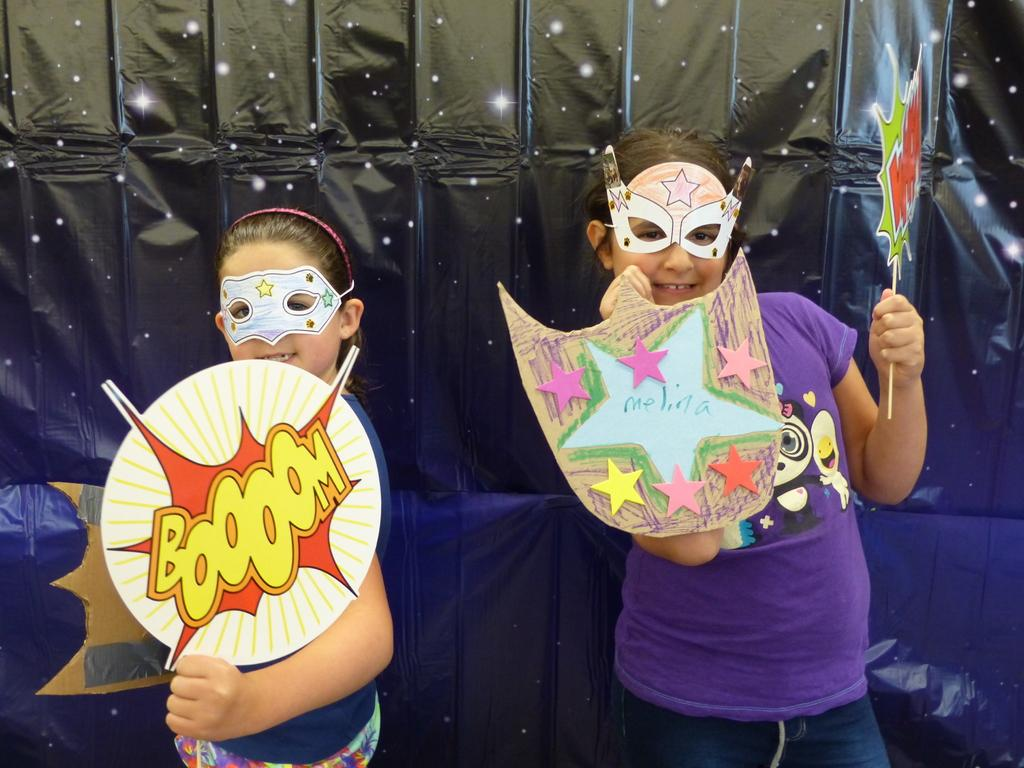Who is present in the image? There are girls in the image. What are the girls wearing on their faces? The girls are wearing masks. What are the girls holding in their hands? The girls are holding boards in their hands. What can be seen in the background of the image? There appears to be a cover in the background of the image. Can you see any wounds on the girls in the image? There is no indication of any wounds on the girls in the image. What type of pot is visible in the image? There is no pot present in the image. 